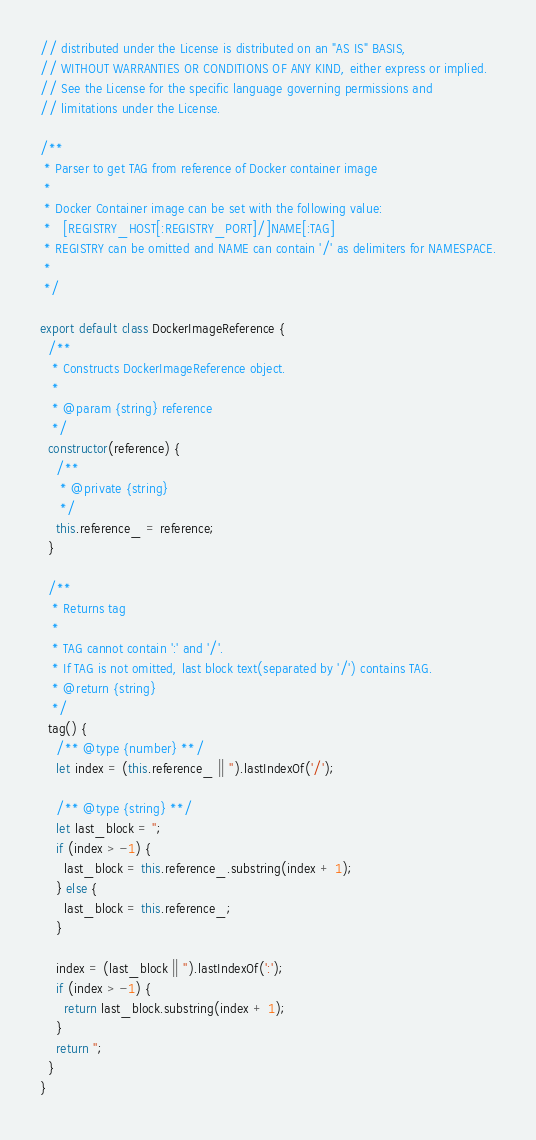Convert code to text. <code><loc_0><loc_0><loc_500><loc_500><_JavaScript_>// distributed under the License is distributed on an "AS IS" BASIS,
// WITHOUT WARRANTIES OR CONDITIONS OF ANY KIND, either express or implied.
// See the License for the specific language governing permissions and
// limitations under the License.

/**
 * Parser to get TAG from reference of Docker container image
 *
 * Docker Container image can be set with the following value:
 *   [REGISTRY_HOST[:REGISTRY_PORT]/]NAME[:TAG]
 * REGISTRY can be omitted and NAME can contain '/' as delimiters for NAMESPACE.
 *
 */

export default class DockerImageReference {
  /**
   * Constructs DockerImageReference object.
   *
   * @param {string} reference
   */
  constructor(reference) {
    /**
     * @private {string}
     */
    this.reference_ = reference;
  }

  /**
   * Returns tag
   *
   * TAG cannot contain ':' and '/'.
   * If TAG is not omitted, last block text(separated by '/') contains TAG.
   * @return {string}
   */
  tag() {
    /** @type {number} **/
    let index = (this.reference_ || '').lastIndexOf('/');

    /** @type {string} **/
    let last_block = '';
    if (index > -1) {
      last_block = this.reference_.substring(index + 1);
    } else {
      last_block = this.reference_;
    }

    index = (last_block || '').lastIndexOf(':');
    if (index > -1) {
      return last_block.substring(index + 1);
    }
    return '';
  }
}
</code> 